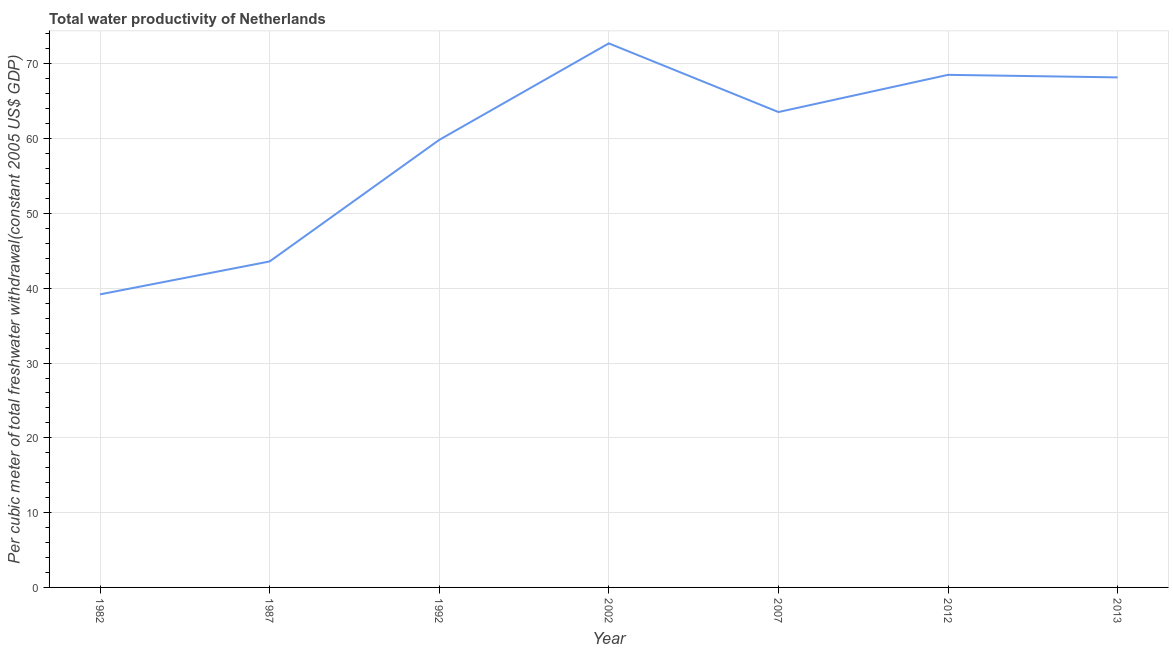What is the total water productivity in 2002?
Offer a terse response. 72.74. Across all years, what is the maximum total water productivity?
Provide a short and direct response. 72.74. Across all years, what is the minimum total water productivity?
Provide a succinct answer. 39.18. In which year was the total water productivity maximum?
Provide a succinct answer. 2002. In which year was the total water productivity minimum?
Offer a terse response. 1982. What is the sum of the total water productivity?
Your answer should be compact. 415.62. What is the difference between the total water productivity in 1992 and 2002?
Offer a very short reply. -12.91. What is the average total water productivity per year?
Offer a very short reply. 59.37. What is the median total water productivity?
Offer a very short reply. 63.56. In how many years, is the total water productivity greater than 10 US$?
Offer a terse response. 7. Do a majority of the years between 2012 and 2002 (inclusive) have total water productivity greater than 18 US$?
Give a very brief answer. No. What is the ratio of the total water productivity in 2007 to that in 2012?
Your answer should be very brief. 0.93. Is the total water productivity in 2012 less than that in 2013?
Your answer should be very brief. No. Is the difference between the total water productivity in 1982 and 1987 greater than the difference between any two years?
Keep it short and to the point. No. What is the difference between the highest and the second highest total water productivity?
Give a very brief answer. 4.21. Is the sum of the total water productivity in 2007 and 2013 greater than the maximum total water productivity across all years?
Offer a terse response. Yes. What is the difference between the highest and the lowest total water productivity?
Provide a succinct answer. 33.56. Does the total water productivity monotonically increase over the years?
Your answer should be compact. No. How many lines are there?
Your answer should be compact. 1. Does the graph contain any zero values?
Make the answer very short. No. What is the title of the graph?
Make the answer very short. Total water productivity of Netherlands. What is the label or title of the Y-axis?
Give a very brief answer. Per cubic meter of total freshwater withdrawal(constant 2005 US$ GDP). What is the Per cubic meter of total freshwater withdrawal(constant 2005 US$ GDP) in 1982?
Provide a short and direct response. 39.18. What is the Per cubic meter of total freshwater withdrawal(constant 2005 US$ GDP) of 1987?
Ensure brevity in your answer.  43.58. What is the Per cubic meter of total freshwater withdrawal(constant 2005 US$ GDP) of 1992?
Your answer should be compact. 59.83. What is the Per cubic meter of total freshwater withdrawal(constant 2005 US$ GDP) of 2002?
Offer a terse response. 72.74. What is the Per cubic meter of total freshwater withdrawal(constant 2005 US$ GDP) of 2007?
Keep it short and to the point. 63.56. What is the Per cubic meter of total freshwater withdrawal(constant 2005 US$ GDP) of 2012?
Your answer should be very brief. 68.53. What is the Per cubic meter of total freshwater withdrawal(constant 2005 US$ GDP) in 2013?
Provide a succinct answer. 68.19. What is the difference between the Per cubic meter of total freshwater withdrawal(constant 2005 US$ GDP) in 1982 and 1987?
Provide a short and direct response. -4.4. What is the difference between the Per cubic meter of total freshwater withdrawal(constant 2005 US$ GDP) in 1982 and 1992?
Your answer should be compact. -20.65. What is the difference between the Per cubic meter of total freshwater withdrawal(constant 2005 US$ GDP) in 1982 and 2002?
Your answer should be very brief. -33.56. What is the difference between the Per cubic meter of total freshwater withdrawal(constant 2005 US$ GDP) in 1982 and 2007?
Your answer should be compact. -24.38. What is the difference between the Per cubic meter of total freshwater withdrawal(constant 2005 US$ GDP) in 1982 and 2012?
Provide a short and direct response. -29.35. What is the difference between the Per cubic meter of total freshwater withdrawal(constant 2005 US$ GDP) in 1982 and 2013?
Your answer should be very brief. -29.01. What is the difference between the Per cubic meter of total freshwater withdrawal(constant 2005 US$ GDP) in 1987 and 1992?
Offer a very short reply. -16.25. What is the difference between the Per cubic meter of total freshwater withdrawal(constant 2005 US$ GDP) in 1987 and 2002?
Offer a very short reply. -29.16. What is the difference between the Per cubic meter of total freshwater withdrawal(constant 2005 US$ GDP) in 1987 and 2007?
Your answer should be compact. -19.98. What is the difference between the Per cubic meter of total freshwater withdrawal(constant 2005 US$ GDP) in 1987 and 2012?
Provide a short and direct response. -24.95. What is the difference between the Per cubic meter of total freshwater withdrawal(constant 2005 US$ GDP) in 1987 and 2013?
Provide a short and direct response. -24.61. What is the difference between the Per cubic meter of total freshwater withdrawal(constant 2005 US$ GDP) in 1992 and 2002?
Offer a very short reply. -12.91. What is the difference between the Per cubic meter of total freshwater withdrawal(constant 2005 US$ GDP) in 1992 and 2007?
Give a very brief answer. -3.73. What is the difference between the Per cubic meter of total freshwater withdrawal(constant 2005 US$ GDP) in 1992 and 2012?
Provide a short and direct response. -8.7. What is the difference between the Per cubic meter of total freshwater withdrawal(constant 2005 US$ GDP) in 1992 and 2013?
Provide a short and direct response. -8.36. What is the difference between the Per cubic meter of total freshwater withdrawal(constant 2005 US$ GDP) in 2002 and 2007?
Ensure brevity in your answer.  9.18. What is the difference between the Per cubic meter of total freshwater withdrawal(constant 2005 US$ GDP) in 2002 and 2012?
Offer a very short reply. 4.21. What is the difference between the Per cubic meter of total freshwater withdrawal(constant 2005 US$ GDP) in 2002 and 2013?
Provide a succinct answer. 4.55. What is the difference between the Per cubic meter of total freshwater withdrawal(constant 2005 US$ GDP) in 2007 and 2012?
Give a very brief answer. -4.97. What is the difference between the Per cubic meter of total freshwater withdrawal(constant 2005 US$ GDP) in 2007 and 2013?
Your answer should be very brief. -4.63. What is the difference between the Per cubic meter of total freshwater withdrawal(constant 2005 US$ GDP) in 2012 and 2013?
Provide a short and direct response. 0.34. What is the ratio of the Per cubic meter of total freshwater withdrawal(constant 2005 US$ GDP) in 1982 to that in 1987?
Provide a succinct answer. 0.9. What is the ratio of the Per cubic meter of total freshwater withdrawal(constant 2005 US$ GDP) in 1982 to that in 1992?
Make the answer very short. 0.66. What is the ratio of the Per cubic meter of total freshwater withdrawal(constant 2005 US$ GDP) in 1982 to that in 2002?
Your response must be concise. 0.54. What is the ratio of the Per cubic meter of total freshwater withdrawal(constant 2005 US$ GDP) in 1982 to that in 2007?
Provide a succinct answer. 0.62. What is the ratio of the Per cubic meter of total freshwater withdrawal(constant 2005 US$ GDP) in 1982 to that in 2012?
Provide a succinct answer. 0.57. What is the ratio of the Per cubic meter of total freshwater withdrawal(constant 2005 US$ GDP) in 1982 to that in 2013?
Ensure brevity in your answer.  0.57. What is the ratio of the Per cubic meter of total freshwater withdrawal(constant 2005 US$ GDP) in 1987 to that in 1992?
Offer a very short reply. 0.73. What is the ratio of the Per cubic meter of total freshwater withdrawal(constant 2005 US$ GDP) in 1987 to that in 2002?
Provide a short and direct response. 0.6. What is the ratio of the Per cubic meter of total freshwater withdrawal(constant 2005 US$ GDP) in 1987 to that in 2007?
Your answer should be very brief. 0.69. What is the ratio of the Per cubic meter of total freshwater withdrawal(constant 2005 US$ GDP) in 1987 to that in 2012?
Your answer should be very brief. 0.64. What is the ratio of the Per cubic meter of total freshwater withdrawal(constant 2005 US$ GDP) in 1987 to that in 2013?
Make the answer very short. 0.64. What is the ratio of the Per cubic meter of total freshwater withdrawal(constant 2005 US$ GDP) in 1992 to that in 2002?
Make the answer very short. 0.82. What is the ratio of the Per cubic meter of total freshwater withdrawal(constant 2005 US$ GDP) in 1992 to that in 2007?
Your answer should be very brief. 0.94. What is the ratio of the Per cubic meter of total freshwater withdrawal(constant 2005 US$ GDP) in 1992 to that in 2012?
Provide a succinct answer. 0.87. What is the ratio of the Per cubic meter of total freshwater withdrawal(constant 2005 US$ GDP) in 1992 to that in 2013?
Make the answer very short. 0.88. What is the ratio of the Per cubic meter of total freshwater withdrawal(constant 2005 US$ GDP) in 2002 to that in 2007?
Your answer should be very brief. 1.14. What is the ratio of the Per cubic meter of total freshwater withdrawal(constant 2005 US$ GDP) in 2002 to that in 2012?
Provide a succinct answer. 1.06. What is the ratio of the Per cubic meter of total freshwater withdrawal(constant 2005 US$ GDP) in 2002 to that in 2013?
Provide a short and direct response. 1.07. What is the ratio of the Per cubic meter of total freshwater withdrawal(constant 2005 US$ GDP) in 2007 to that in 2012?
Provide a short and direct response. 0.93. What is the ratio of the Per cubic meter of total freshwater withdrawal(constant 2005 US$ GDP) in 2007 to that in 2013?
Your answer should be compact. 0.93. What is the ratio of the Per cubic meter of total freshwater withdrawal(constant 2005 US$ GDP) in 2012 to that in 2013?
Ensure brevity in your answer.  1. 